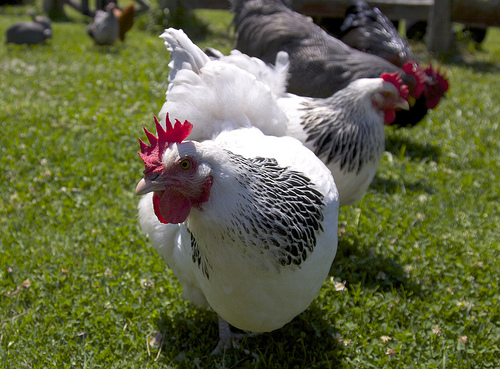<image>
Can you confirm if the beak is on the chicken? No. The beak is not positioned on the chicken. They may be near each other, but the beak is not supported by or resting on top of the chicken. Is there a chicken behind the grass? No. The chicken is not behind the grass. From this viewpoint, the chicken appears to be positioned elsewhere in the scene. Is the chicken to the right of the chicken? No. The chicken is not to the right of the chicken. The horizontal positioning shows a different relationship. Is the hen next to the grass? No. The hen is not positioned next to the grass. They are located in different areas of the scene. 